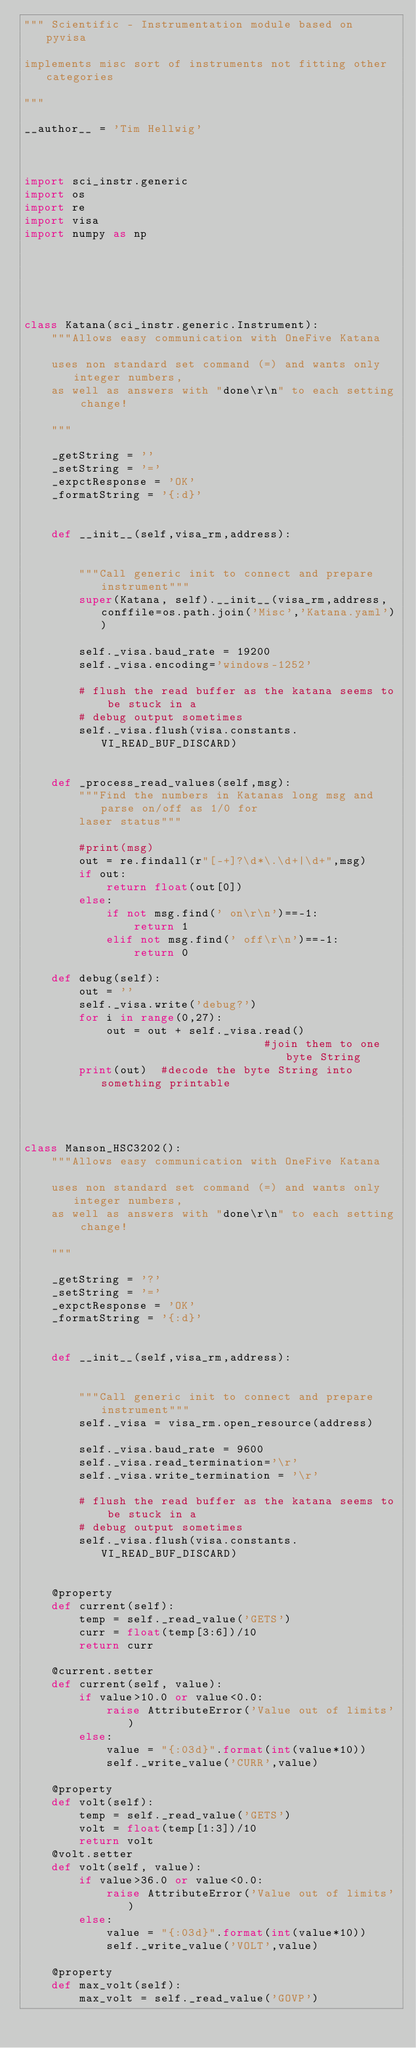Convert code to text. <code><loc_0><loc_0><loc_500><loc_500><_Python_>""" Scientific - Instrumentation module based on pyvisa

implements misc sort of instruments not fitting other categories

"""

__author__ = 'Tim Hellwig'



import sci_instr.generic
import os
import re
import visa
import numpy as np



        


class Katana(sci_instr.generic.Instrument):
    """Allows easy communication with OneFive Katana
    
    uses non standard set command (=) and wants only integer numbers,
    as well as answers with "done\r\n" to each setting change!
    
    """  
    
    _getString = ''
    _setString = '='
    _expctResponse = 'OK'
    _formatString = '{:d}'
    
    
    def __init__(self,visa_rm,address):
        
        
        """Call generic init to connect and prepare instrument"""
        super(Katana, self).__init__(visa_rm,address,conffile=os.path.join('Misc','Katana.yaml'))
        
        self._visa.baud_rate = 19200
        self._visa.encoding='windows-1252'
        
        # flush the read buffer as the katana seems to be stuck in a
        # debug output sometimes
        self._visa.flush(visa.constants.VI_READ_BUF_DISCARD)


    def _process_read_values(self,msg):
        """Find the numbers in Katanas long msg and parse on/off as 1/0 for
        laser status"""
        
        #print(msg)
        out = re.findall(r"[-+]?\d*\.\d+|\d+",msg)
        if out:
            return float(out[0])
        else:
            if not msg.find(' on\r\n')==-1:
                return 1
            elif not msg.find(' off\r\n')==-1:
                return 0
                
    def debug(self):
        out = ''
        self._visa.write('debug?')
        for i in range(0,27):
            out = out + self._visa.read()
                                   #join them to one byte String
        print(out)  #decode the byte String into something printable
        
        


class Manson_HSC3202():
    """Allows easy communication with OneFive Katana
    
    uses non standard set command (=) and wants only integer numbers,
    as well as answers with "done\r\n" to each setting change!
    
    """  
    
    _getString = '?'
    _setString = '='
    _expctResponse = 'OK'
    _formatString = '{:d}'
    
    
    def __init__(self,visa_rm,address):
        
        
        """Call generic init to connect and prepare instrument"""
        self._visa = visa_rm.open_resource(address)
        
        self._visa.baud_rate = 9600
        self._visa.read_termination='\r'
        self._visa.write_termination = '\r'
        
        # flush the read buffer as the katana seems to be stuck in a
        # debug output sometimes
        self._visa.flush(visa.constants.VI_READ_BUF_DISCARD)

    
    @property
    def current(self):
        temp = self._read_value('GETS')
        curr = float(temp[3:6])/10
        return curr

    @current.setter
    def current(self, value):
        if value>10.0 or value<0.0:
            raise AttributeError('Value out of limits')
        else:
            value = "{:03d}".format(int(value*10))
            self._write_value('CURR',value)
            
    @property
    def volt(self):
        temp = self._read_value('GETS')
        volt = float(temp[1:3])/10
        return volt
    @volt.setter
    def volt(self, value):
        if value>36.0 or value<0.0:
            raise AttributeError('Value out of limits')
        else:
            value = "{:03d}".format(int(value*10))
            self._write_value('VOLT',value)
            
    @property
    def max_volt(self):
        max_volt = self._read_value('GOVP')</code> 